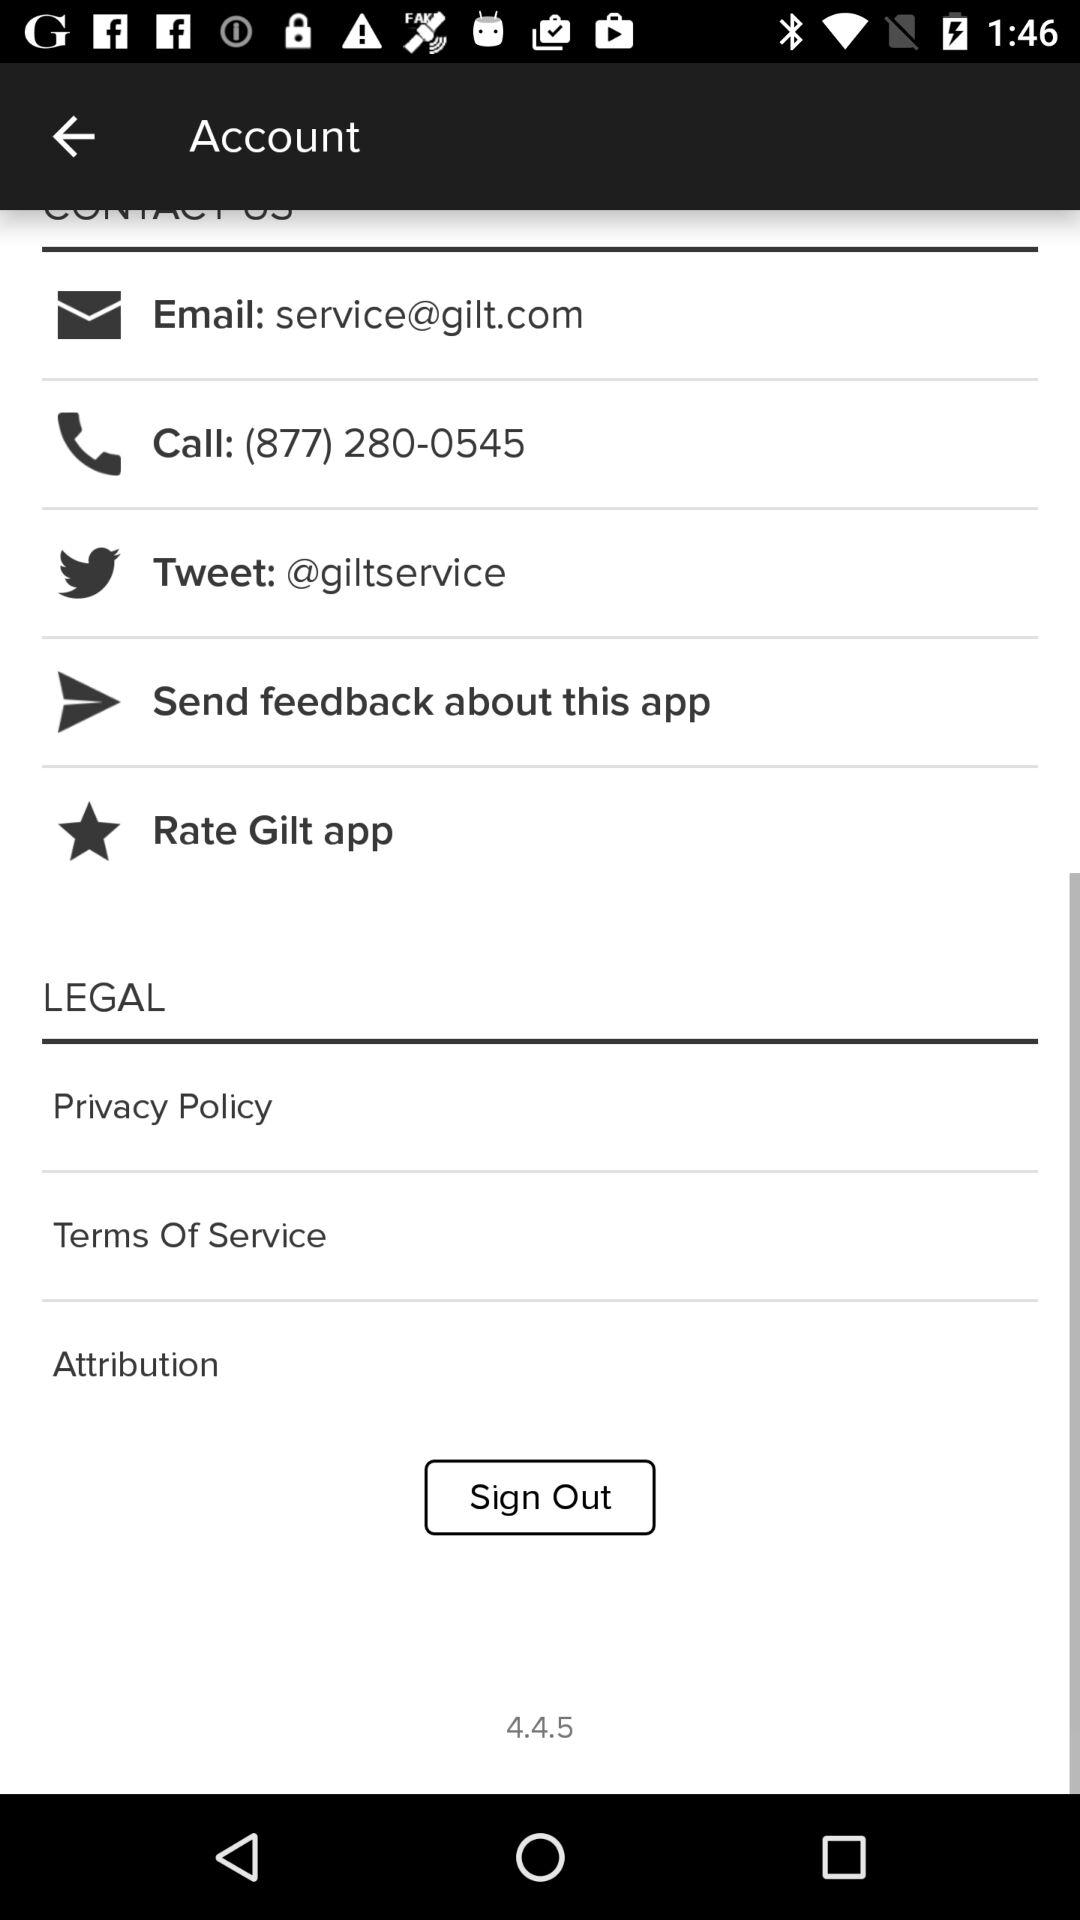What is the given number to call? The given number is (877) 280-0545. 